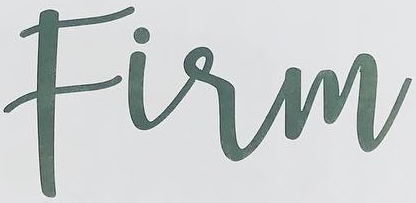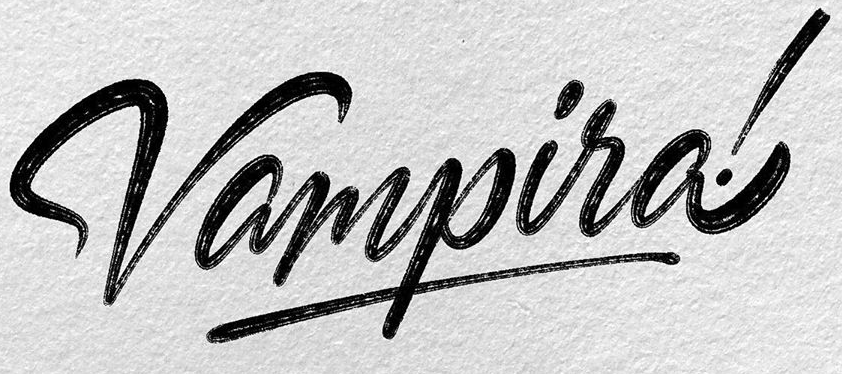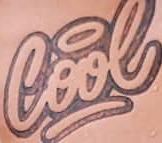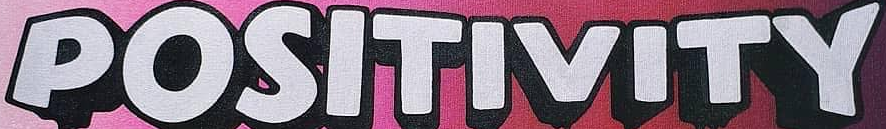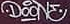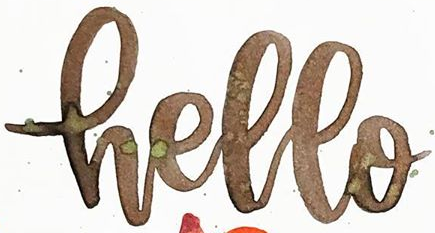Read the text from these images in sequence, separated by a semicolon. Firm; Vampira!; Cool; POSITIVITY; DOONE; Hello 